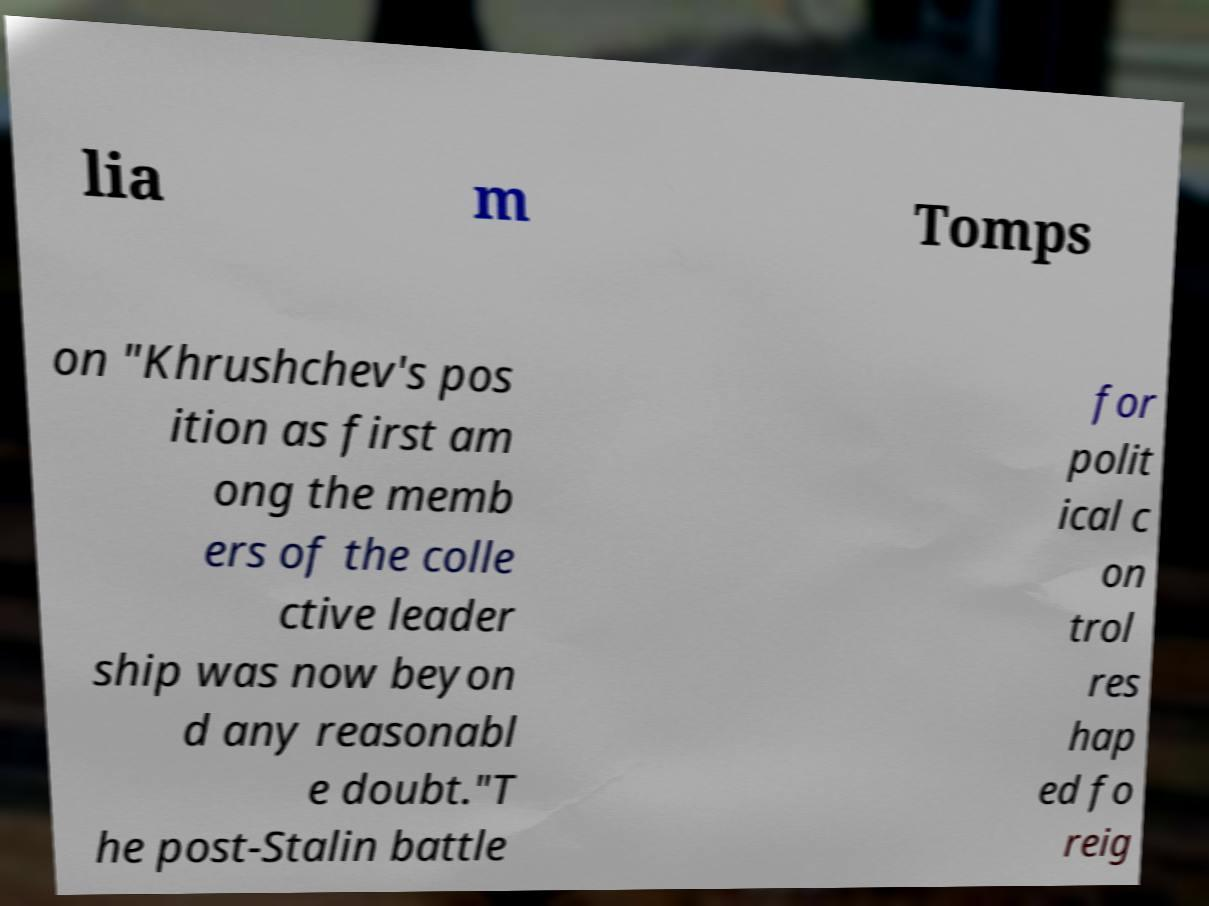I need the written content from this picture converted into text. Can you do that? lia m Tomps on "Khrushchev's pos ition as first am ong the memb ers of the colle ctive leader ship was now beyon d any reasonabl e doubt."T he post-Stalin battle for polit ical c on trol res hap ed fo reig 